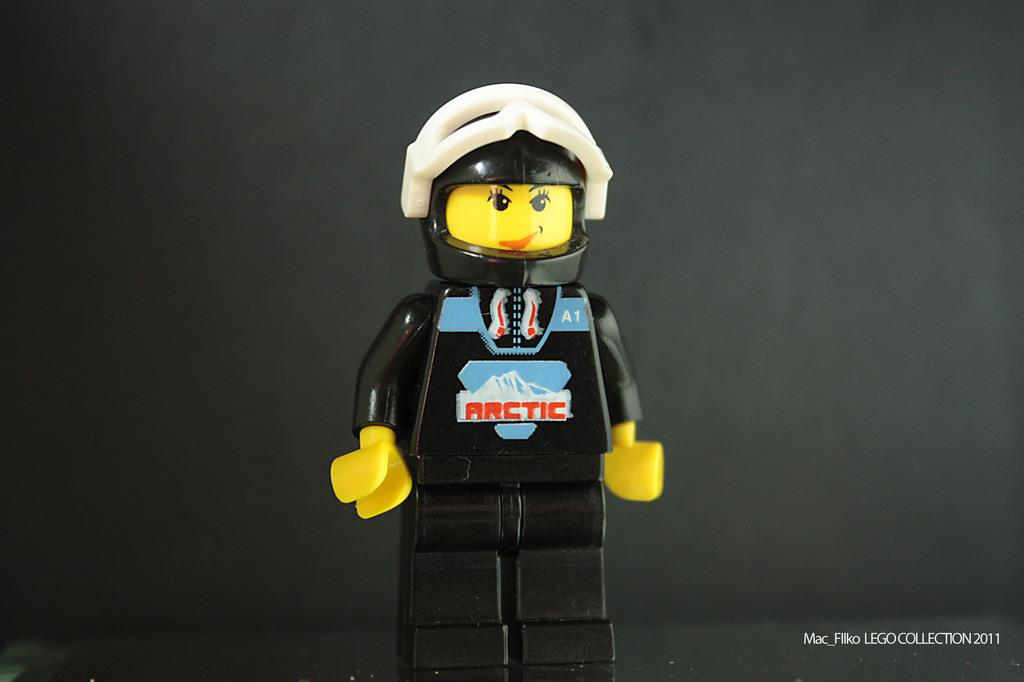What type of toy is in the image? There is a black color toy in the image, and it resembles a person. What can be seen in the background of the image? There is a wall in the background of the image. Is there any text present in the image? Yes, there is some text in the bottom right corner of the image. What type of territory does the toy claim in the image? The toy does not claim any territory in the image, as it is an inanimate object and cannot make such claims. 